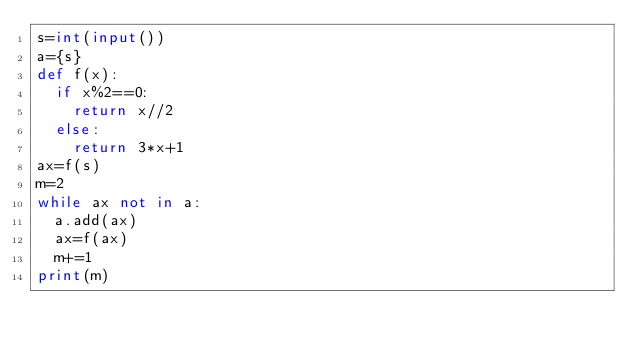<code> <loc_0><loc_0><loc_500><loc_500><_Python_>s=int(input())
a={s}
def f(x):
  if x%2==0:
    return x//2
  else:
    return 3*x+1
ax=f(s)
m=2
while ax not in a:
  a.add(ax)
  ax=f(ax)
  m+=1
print(m)</code> 